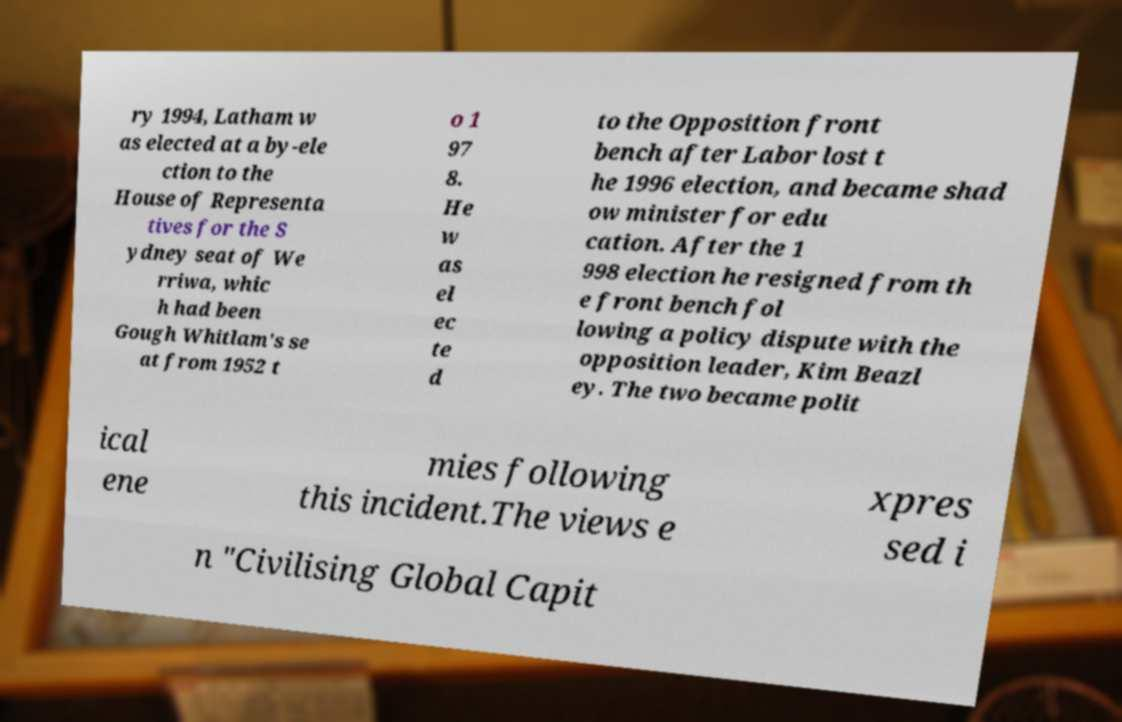Could you extract and type out the text from this image? ry 1994, Latham w as elected at a by-ele ction to the House of Representa tives for the S ydney seat of We rriwa, whic h had been Gough Whitlam's se at from 1952 t o 1 97 8. He w as el ec te d to the Opposition front bench after Labor lost t he 1996 election, and became shad ow minister for edu cation. After the 1 998 election he resigned from th e front bench fol lowing a policy dispute with the opposition leader, Kim Beazl ey. The two became polit ical ene mies following this incident.The views e xpres sed i n "Civilising Global Capit 